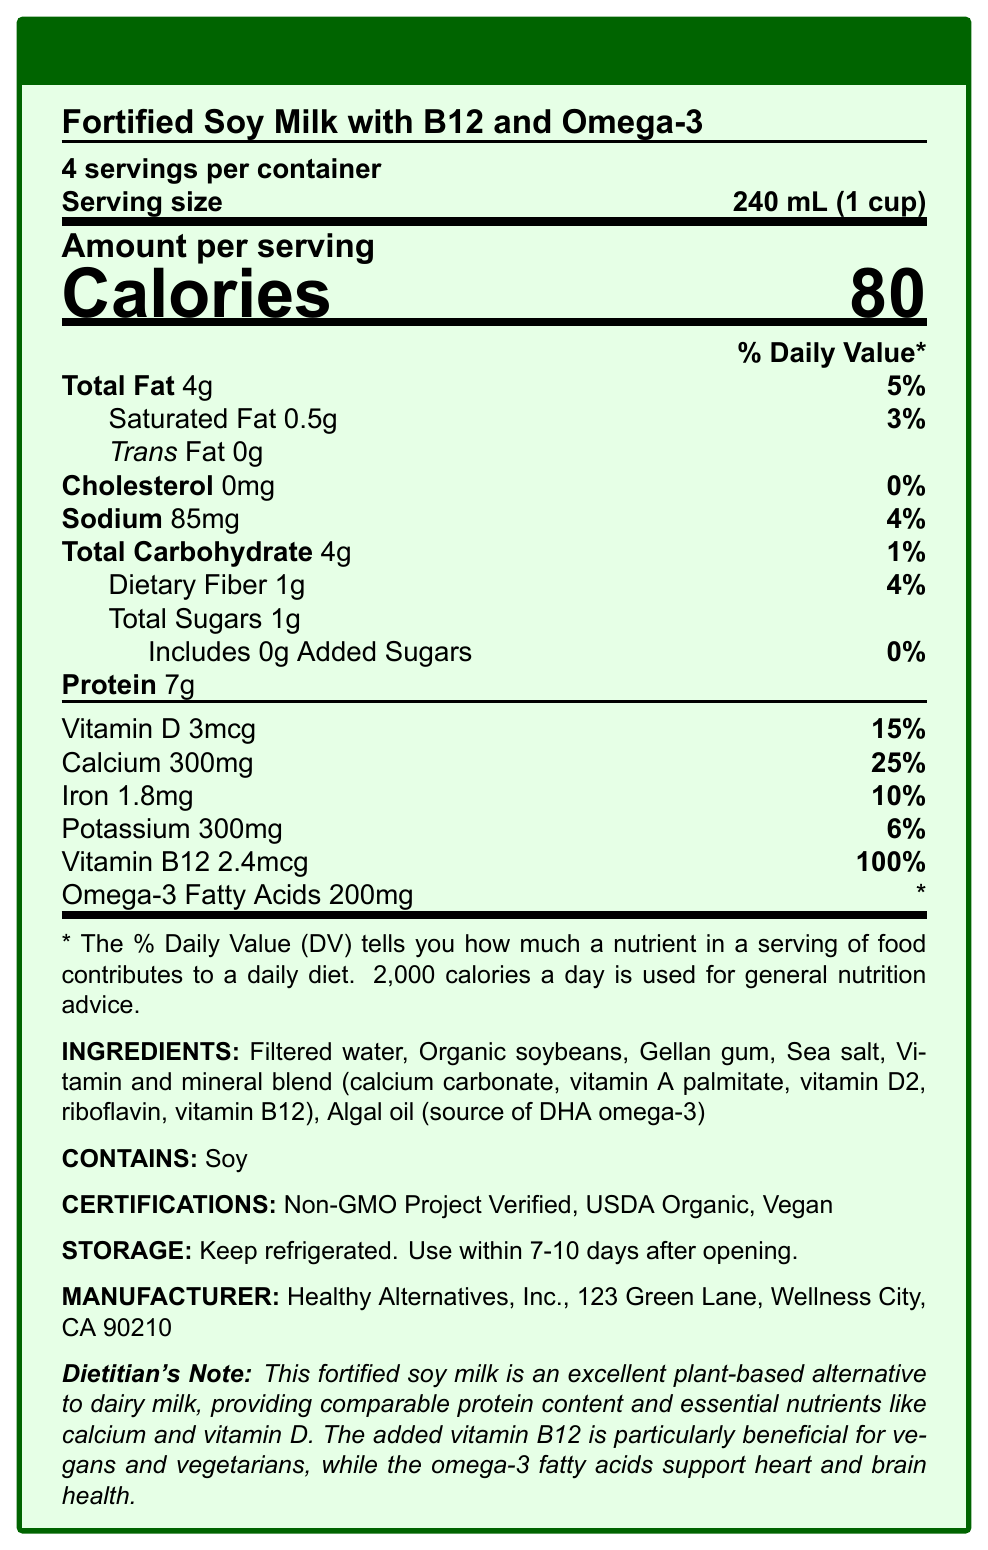what is the product name? The product name is stated at the top of the document under the title "Nutrition Facts".
Answer: Fortified Soy Milk with B12 and Omega-3 what is the serving size? The serving size is indicated right under the information "4 servings per container".
Answer: 240 mL (1 cup) how many calories are in one serving? The number of calories per serving is stated in large font under "Amount per serving".
Answer: 80 What percentage of the daily value of calcium is provided per serving? This is listed under the nutrient information, specifically for calcium.
Answer: 25% how much total fat is in one serving? The amount of total fat is listed under "Total Fat".
Answer: 4g which nutrient is present at 100% of the daily value per serving? A. Vitamin D B. Calcium C. Vitamin B12 The document lists vitamin B12 as having 100% of the daily value per serving.
Answer: C. Vitamin B12 how much omega-3 fatty acids are in one serving? A. 100mg B. 200mg C. 300mg D. 400mg The document states that one serving contains 200mg of omega-3 fatty acids.
Answer: B. 200mg how many grams of added sugars are in one serving? The nutrition facts list shows that there are 0g of added sugars per serving.
Answer: 0g Is this soy milk vegan? The document indicates this product is certified vegan under the "CERTIFICATIONS" section.
Answer: Yes Are there any allergens in this product? The document contains an allergen information section that states it contains soy.
Answer: Yes, Soy Summarize the main benefits of this soy milk as stated in the Dietitian's Note. The Dietitian's Note highlights that this soy milk offers essential nutrients, is beneficial for vegans, and helps support heart and brain health.
Answer: This soy milk is a great plant-based alternative to dairy milk, providing comparable protein and essential nutrients like calcium and vitamin D. It is particularly beneficial for vegans due to added vitamin B12 and supports heart and brain health with omega-3 fatty acids. how much sodium is in one serving? The amount of sodium per serving is clearly listed next to sodium in the nutrient section.
Answer: 85mg how much protein can be found in one serving? The protein content per serving is listed directly under "Protein".
Answer: 7g Is the product Non-GMO certified? The certification section states that the product is Non-GMO Project Verified.
Answer: Yes who is the manufacturer of this product? The manufacturer information provided at the end of the document indicates Healthy Alternatives, Inc.
Answer: Healthy Alternatives, Inc. what are the storage instructions for this soy milk? The storage instructions state that the product should be kept refrigerated and used within 7-10 days after opening.
Answer: Keep refrigerated. Use within 7-10 days after opening. how many servings are there per container? A. 2 B. 4 C. 6 D. 8 The document specifies that there are 4 servings per container.
Answer: B. 4 What is the address of the manufacturer? The manufacturer information section lists the address.
Answer: 123 Green Lane, Wellness City, CA 90210 what percentage of the daily value of protein is provided per serving? The percentage of the daily value for protein is not provided in the document.
Answer: Not enough information 